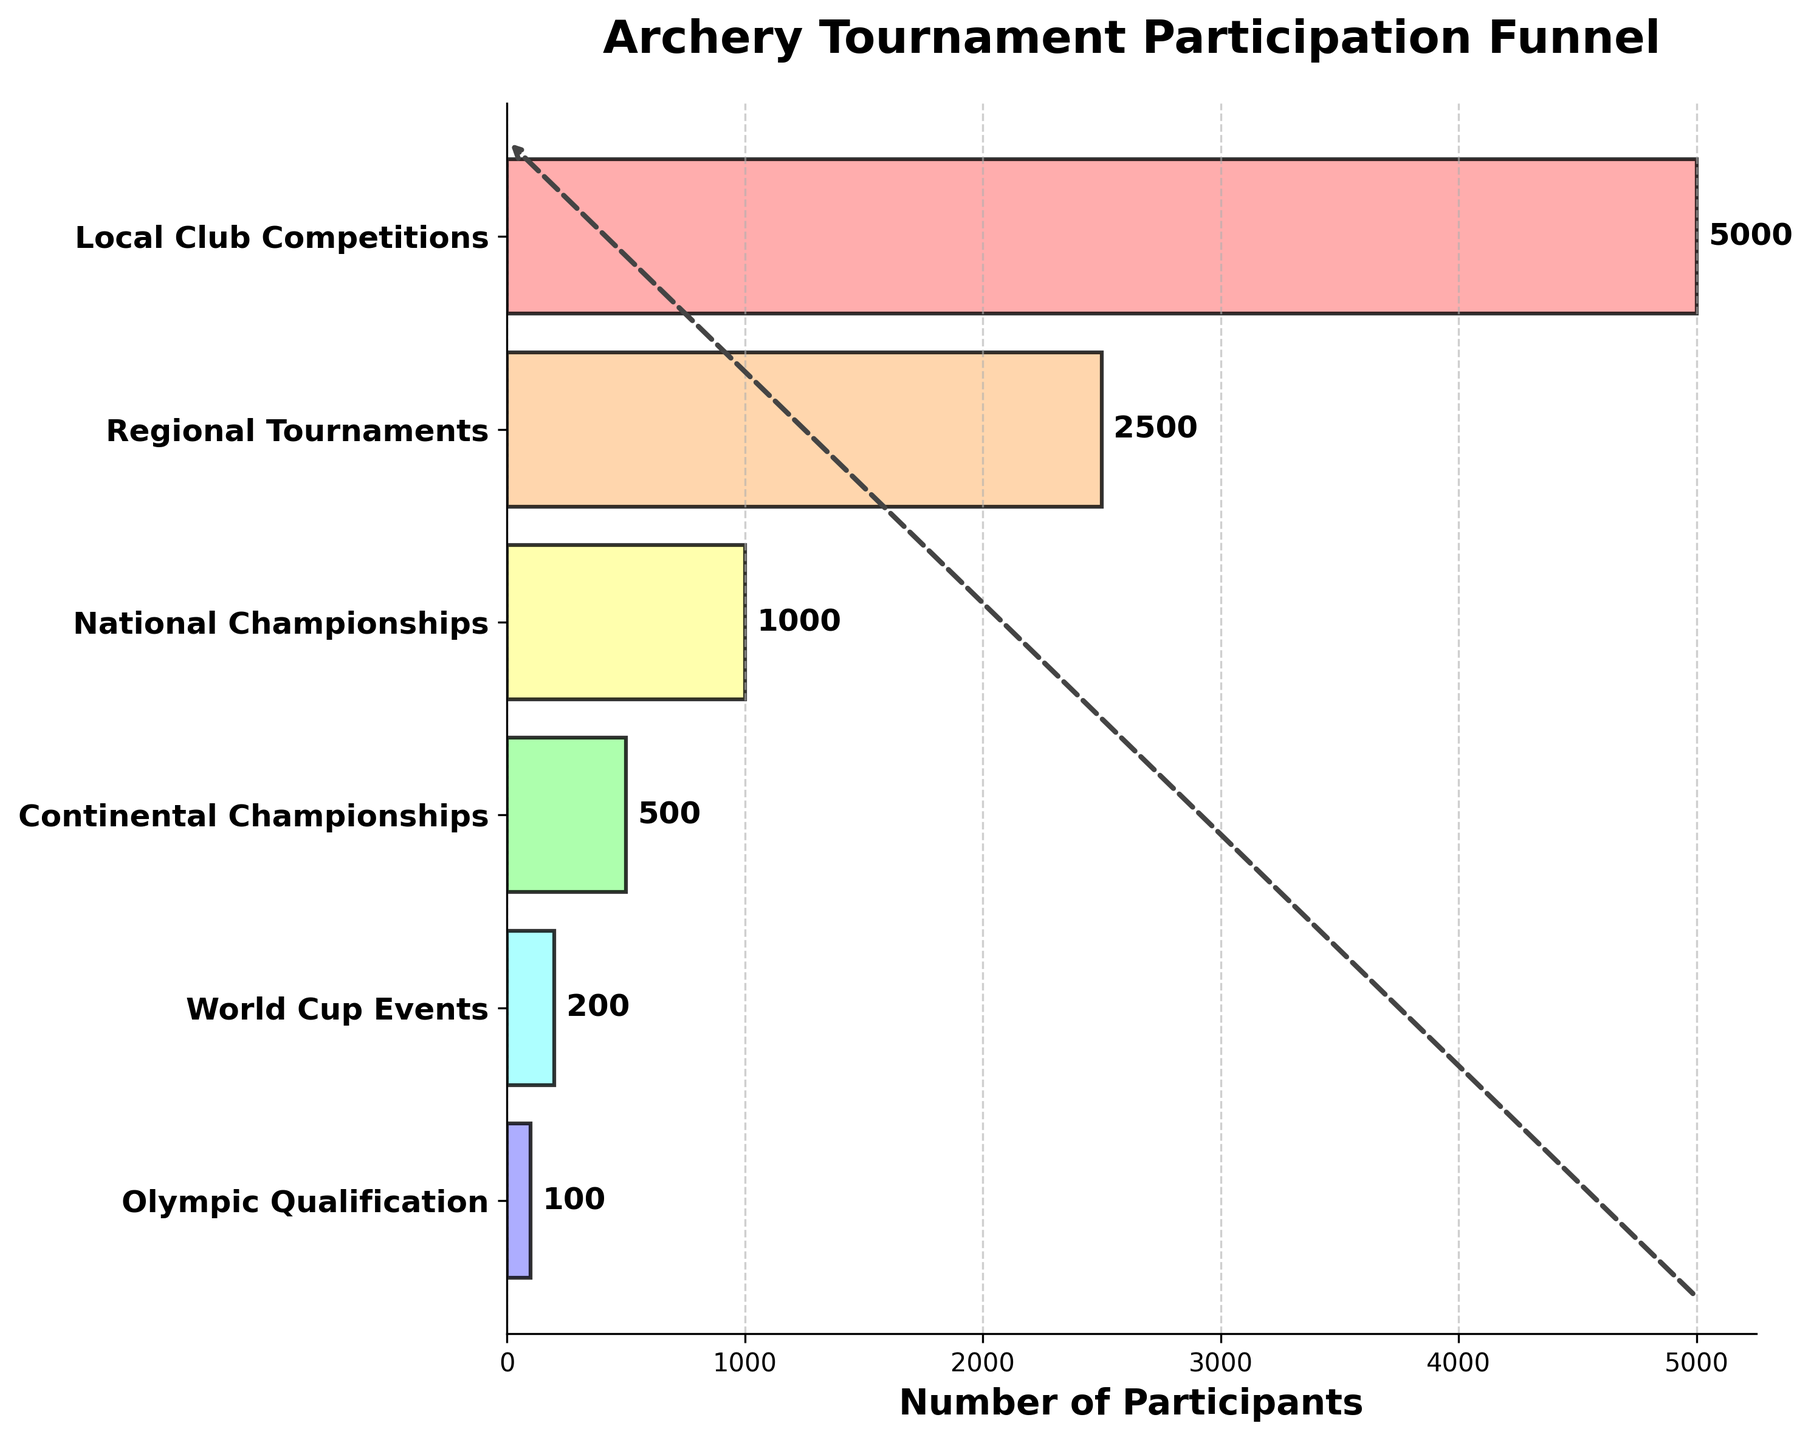What is the title of the chart? The title is located at the top of the chart in large, bold text.
Answer: Archery Tournament Participation Funnel What is the total number of participants at the Local Club Competitions stage? The number of participants is shown next to the bar for each stage. For the Local Club Competitions stage, the label shows 5000.
Answer: 5000 How many stages are presented in the funnel chart? Count the number of different stages listed on the y-axis of the chart. There are six different stages listed.
Answer: 6 What is the percentage reduction in participants from Local Club Competitions to Regional Tournaments? Subtract the number of Regional Tournaments participants from Local Club Competitions participants, then divide by Local Club Competitions participants. Multiply by 100 to get the percentage. Calculation: ((5000 - 2500) / 5000) * 100 = 50%
Answer: 50% Which stage has the least number of participants? Identify the stage with the smallest bar and number label. The smallest value is at the Olympic Qualification stage.
Answer: Olympic Qualification What is the combined number of participants for National Championships and Continental Championships? Add the number of participants at the National Championships stage (1000) to those at the Continental Championships stage (500). 1000 + 500 = 1500
Answer: 1500 How does the number of participants at the World Cup Events stage compare to the Continental Championships stage? The World Cup Events stage has 200 participants, while the Continental Championships stage has 500 participants. 200 is less than 500.
Answer: Less What is the average number of participants from Regional Tournaments to Olympic Qualification stages? Add the number of participants from each of these stages: 2500 (Regional) + 1000 (National) + 500 (Continental) + 200 (World Cup) + 100 (Olympic) = 4300. Divide by the number of stages, 4300 / 5 = 860.
Answer: 860 By how many participants does the number decrease from World Cup Events to Olympic Qualification? Subtract the number of participants in the Olympic Qualification stage from those in the World Cup Events stage: 200 - 100 = 100.
Answer: 100 What insights can you infer about the trend in participation from local to international levels? The chart shows a significant decrease in the number of participants from Local Club Competitions to Olympic Qualification, indicating higher competition and more stringent qualifications at higher levels.
Answer: Participation decreases significantly at higher levels 